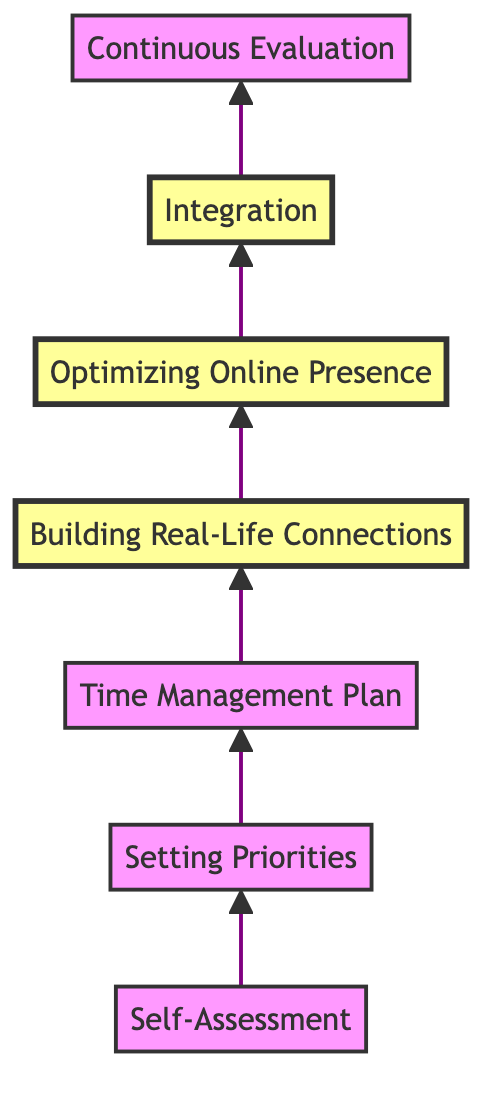What is the title of the first stage? The first stage of the flowchart is labeled "Self-Assessment." It is the starting point in the process of finding balance between virtual and real-life friendships.
Answer: Self-Assessment How many total stages are in the flowchart? By counting each of the individual stages listed from "Self-Assessment" to "Continuous Evaluation," there are a total of seven stages.
Answer: 7 Which stage comes after "Time Management Plan"? According to the diagram, "Building Real-Life Connections" directly follows "Time Management Plan," indicating the next step in the sequence.
Answer: Building Real-Life Connections What is the focus of the "Optimizing Online Presence" stage? The description for "Optimizing Online Presence" highlights curating online interactions to focus on meaningful connections rather than engaging in non-essential activities.
Answer: Curate meaningful connections What stage emphasizes engaging in activities that foster in-person friendships? The description for "Building Real-Life Connections" specifies engaging in activities such as joining clubs or attending social events to enhance in-person friendships.
Answer: Building Real-Life Connections What is the main objective of the "Integration" stage? The "Integration" stage aims to blend both virtual and real-life friendships, which includes planning events for online friends to meet in person or joining virtual meetups with real-life friends.
Answer: Blend virtual and real-life friendships Which stages are highlighted in the diagram? The highlighted stages in the diagram are "Building Real-Life Connections," "Optimizing Online Presence," and "Integration," indicating their importance in finding balance.
Answer: Building Real-Life Connections, Optimizing Online Presence, Integration What is the final stage of the process? The last stage listed in the flowchart is "Continuous Evaluation," which involves regularly revisiting and adjusting one's balance strategy regarding social interactions.
Answer: Continuous Evaluation 